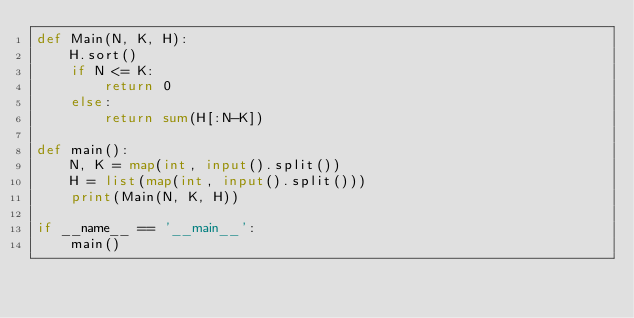Convert code to text. <code><loc_0><loc_0><loc_500><loc_500><_Python_>def Main(N, K, H):
    H.sort()
    if N <= K:
        return 0
    else:
        return sum(H[:N-K])

def main():
    N, K = map(int, input().split())
    H = list(map(int, input().split()))
    print(Main(N, K, H))

if __name__ == '__main__':
    main()</code> 